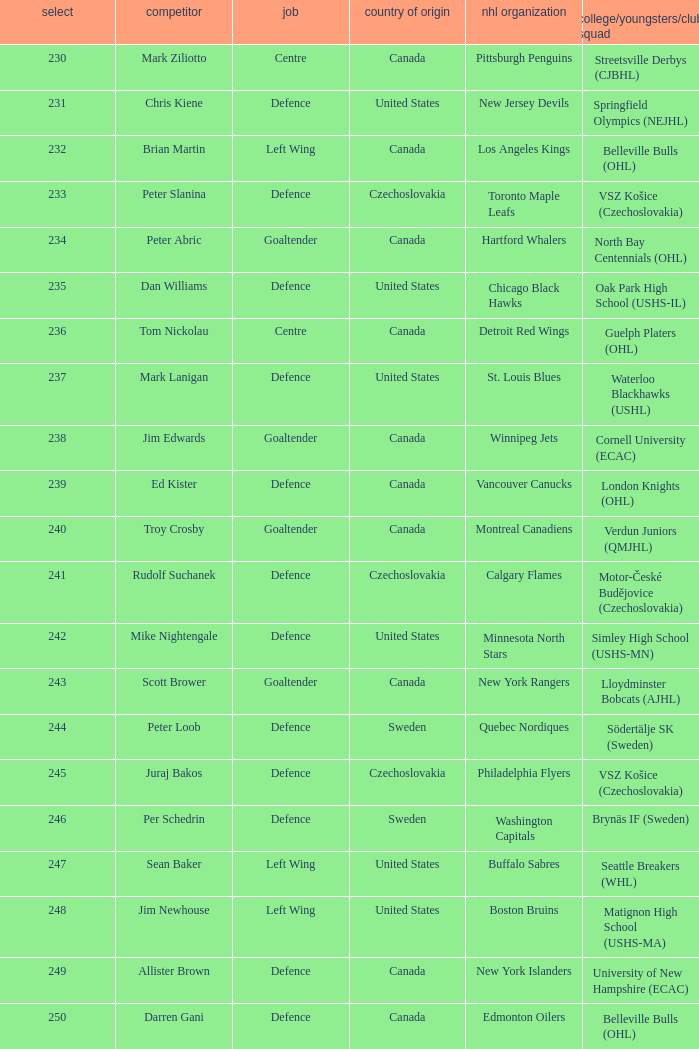What position does allister brown play. Defence. Parse the full table. {'header': ['select', 'competitor', 'job', 'country of origin', 'nhl organization', 'college/youngsters/club squad'], 'rows': [['230', 'Mark Ziliotto', 'Centre', 'Canada', 'Pittsburgh Penguins', 'Streetsville Derbys (CJBHL)'], ['231', 'Chris Kiene', 'Defence', 'United States', 'New Jersey Devils', 'Springfield Olympics (NEJHL)'], ['232', 'Brian Martin', 'Left Wing', 'Canada', 'Los Angeles Kings', 'Belleville Bulls (OHL)'], ['233', 'Peter Slanina', 'Defence', 'Czechoslovakia', 'Toronto Maple Leafs', 'VSZ Košice (Czechoslovakia)'], ['234', 'Peter Abric', 'Goaltender', 'Canada', 'Hartford Whalers', 'North Bay Centennials (OHL)'], ['235', 'Dan Williams', 'Defence', 'United States', 'Chicago Black Hawks', 'Oak Park High School (USHS-IL)'], ['236', 'Tom Nickolau', 'Centre', 'Canada', 'Detroit Red Wings', 'Guelph Platers (OHL)'], ['237', 'Mark Lanigan', 'Defence', 'United States', 'St. Louis Blues', 'Waterloo Blackhawks (USHL)'], ['238', 'Jim Edwards', 'Goaltender', 'Canada', 'Winnipeg Jets', 'Cornell University (ECAC)'], ['239', 'Ed Kister', 'Defence', 'Canada', 'Vancouver Canucks', 'London Knights (OHL)'], ['240', 'Troy Crosby', 'Goaltender', 'Canada', 'Montreal Canadiens', 'Verdun Juniors (QMJHL)'], ['241', 'Rudolf Suchanek', 'Defence', 'Czechoslovakia', 'Calgary Flames', 'Motor-České Budějovice (Czechoslovakia)'], ['242', 'Mike Nightengale', 'Defence', 'United States', 'Minnesota North Stars', 'Simley High School (USHS-MN)'], ['243', 'Scott Brower', 'Goaltender', 'Canada', 'New York Rangers', 'Lloydminster Bobcats (AJHL)'], ['244', 'Peter Loob', 'Defence', 'Sweden', 'Quebec Nordiques', 'Södertälje SK (Sweden)'], ['245', 'Juraj Bakos', 'Defence', 'Czechoslovakia', 'Philadelphia Flyers', 'VSZ Košice (Czechoslovakia)'], ['246', 'Per Schedrin', 'Defence', 'Sweden', 'Washington Capitals', 'Brynäs IF (Sweden)'], ['247', 'Sean Baker', 'Left Wing', 'United States', 'Buffalo Sabres', 'Seattle Breakers (WHL)'], ['248', 'Jim Newhouse', 'Left Wing', 'United States', 'Boston Bruins', 'Matignon High School (USHS-MA)'], ['249', 'Allister Brown', 'Defence', 'Canada', 'New York Islanders', 'University of New Hampshire (ECAC)'], ['250', 'Darren Gani', 'Defence', 'Canada', 'Edmonton Oilers', 'Belleville Bulls (OHL)']]} 